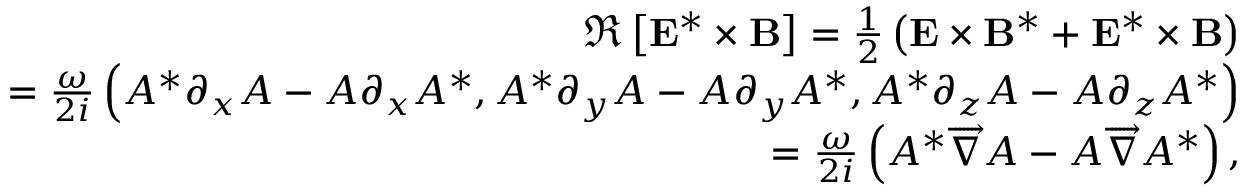Convert formula to latex. <formula><loc_0><loc_0><loc_500><loc_500>\begin{array} { r l r } & { \Re \left [ { E } ^ { * } \times { B } \right ] = \frac { 1 } { 2 } \left ( { E } \times { B } ^ { * } + { E } ^ { * } \times { B } \right ) } \\ & { = \frac { \omega } { 2 i } \left ( A ^ { * } \partial _ { x } A - A \partial _ { x } A ^ { * } , A ^ { * } \partial _ { y } A - A \partial _ { y } A ^ { * } , A ^ { * } \partial _ { z } A - A \partial _ { z } A ^ { * } \right ) } \\ & { = \frac { \omega } { 2 i } \left ( A ^ { * } \overrightarrow { \nabla } A - A \overrightarrow { \nabla } A ^ { * } \right ) , } \end{array}</formula> 